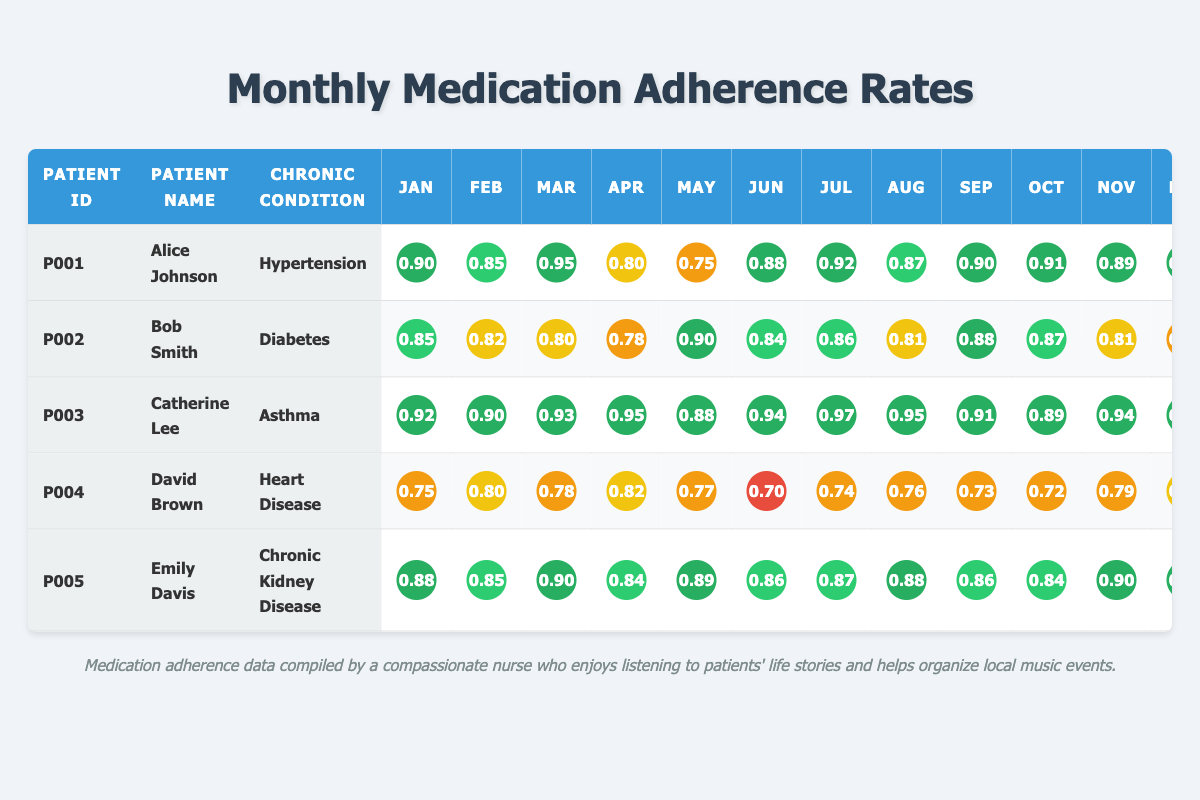What was Alice Johnson's medication adherence rate in March? Looking at the row for Alice Johnson, the adherence rate in March is listed as 0.95.
Answer: 0.95 What is the chronic condition of Bob Smith? In the row for Bob Smith, the chronic condition is labeled as Diabetes.
Answer: Diabetes In which month did David Brown show the lowest adherence? By checking David Brown's adherence rates across all months, the lowest is 0.70 in June.
Answer: June What is the average adherence rate for Catherine Lee over the year? To find the average, sum Catherine Lee's monthly adherence rates (0.92 + 0.90 + 0.93 + 0.95 + 0.88 + 0.94 + 0.97 + 0.95 + 0.91 + 0.89 + 0.94 + 0.96 = 11.38) and then divide by 12, giving 11.38/12 = 0.9483.
Answer: 0.9483 Did Emily Davis have an adherence rate above 0.90 in any month? Checking Emily Davis's adherence rates, she had values above 0.90 in January (0.88) but not above 0.90 in any other month. The adherence rates are all below or equal to 0.90 in other months.
Answer: No Which patient had the highest adherence in July? Review each patient's adherence rate for July; Catherine Lee had 0.97, which is the highest in that month compared to others.
Answer: Catherine Lee Is Bob Smith's adherence rate in December higher than David Brown's in November? Bob Smith's December adherence is 0.79, while David Brown's November adherence is 0.79 as well, so they are equal.
Answer: No What was the total adherence rate for Emily Davis from January to March? Sum Emily Davis's adherence rates for these months: January (0.88) + February (0.85) + March (0.90) = 0.88 + 0.85 + 0.90 = 2.63.
Answer: 2.63 In which month did more than half the patients have an adherence above 0.85? Analyzing the adherence rates for each month, in May, Alice (0.75), Bob (0.90), Catherine (0.88), David (0.77), and Emily (0.89) show that 4 out of 5 patients are above 0.85, thus satisfying the condition.
Answer: May What is the difference between the highest and lowest adherence rate recorded for any patient in December? The highest adherence in December is 0.96 (Catherine), and the lowest is 0.79 (Bob). The difference is 0.96 - 0.79 = 0.17.
Answer: 0.17 